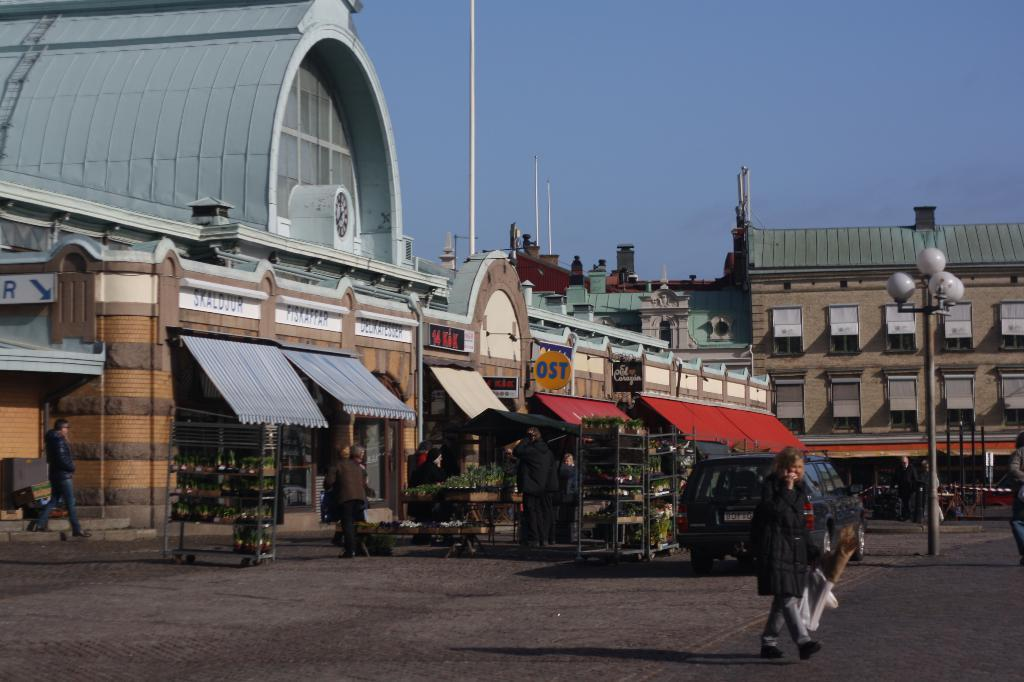What is the person in the image doing? The person is walking and holding an object. What can be seen on the surface in the image? There is a car on the surface. Who else is present in the image besides the person walking? There are people visible in the image. What is attached to the pole in the image? There are lights on a pole. What type of structures are present in the image? There are buildings and stores in the image. What part of the natural environment is visible in the image? The sky is visible in the image. What type of finger can be seen playing the bells in the image? There are no bells or fingers present in the image. Is there a cobweb visible on the buildings in the image? There is no mention of a cobweb in the image, and it cannot be determined from the provided facts. 